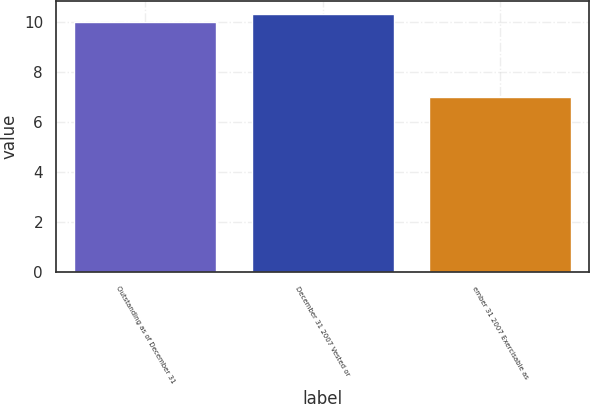<chart> <loc_0><loc_0><loc_500><loc_500><bar_chart><fcel>Outstanding as of December 31<fcel>December 31 2007 Vested or<fcel>ember 31 2007 Exercisable as<nl><fcel>10<fcel>10.3<fcel>7<nl></chart> 